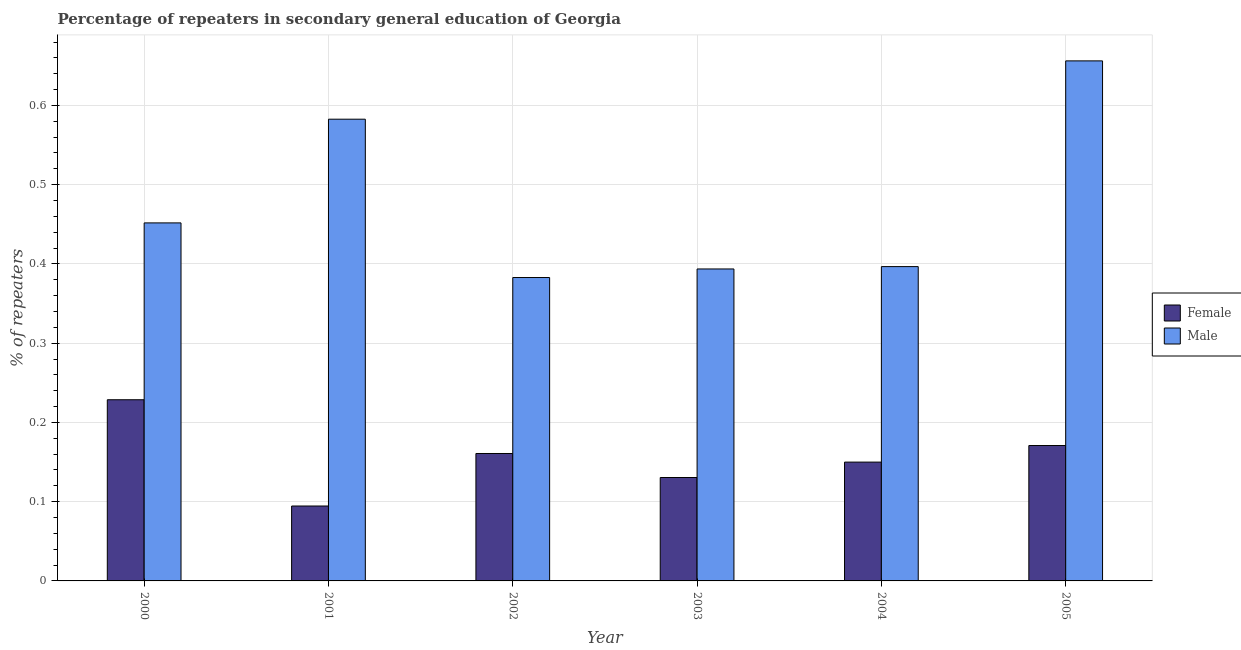Are the number of bars on each tick of the X-axis equal?
Provide a succinct answer. Yes. How many bars are there on the 2nd tick from the right?
Keep it short and to the point. 2. What is the label of the 5th group of bars from the left?
Give a very brief answer. 2004. In how many cases, is the number of bars for a given year not equal to the number of legend labels?
Give a very brief answer. 0. What is the percentage of male repeaters in 2001?
Provide a succinct answer. 0.58. Across all years, what is the maximum percentage of female repeaters?
Your answer should be very brief. 0.23. Across all years, what is the minimum percentage of male repeaters?
Give a very brief answer. 0.38. In which year was the percentage of male repeaters maximum?
Ensure brevity in your answer.  2005. What is the total percentage of male repeaters in the graph?
Your answer should be compact. 2.86. What is the difference between the percentage of female repeaters in 2000 and that in 2004?
Ensure brevity in your answer.  0.08. What is the difference between the percentage of female repeaters in 2001 and the percentage of male repeaters in 2004?
Make the answer very short. -0.06. What is the average percentage of female repeaters per year?
Provide a succinct answer. 0.16. What is the ratio of the percentage of male repeaters in 2002 to that in 2003?
Your answer should be compact. 0.97. Is the percentage of female repeaters in 2004 less than that in 2005?
Offer a very short reply. Yes. Is the difference between the percentage of male repeaters in 2003 and 2005 greater than the difference between the percentage of female repeaters in 2003 and 2005?
Make the answer very short. No. What is the difference between the highest and the second highest percentage of male repeaters?
Your answer should be very brief. 0.07. What is the difference between the highest and the lowest percentage of male repeaters?
Provide a short and direct response. 0.27. In how many years, is the percentage of female repeaters greater than the average percentage of female repeaters taken over all years?
Keep it short and to the point. 3. Is the sum of the percentage of female repeaters in 2003 and 2004 greater than the maximum percentage of male repeaters across all years?
Your response must be concise. Yes. What does the 2nd bar from the left in 2005 represents?
Provide a succinct answer. Male. How many bars are there?
Provide a succinct answer. 12. Are all the bars in the graph horizontal?
Give a very brief answer. No. Are the values on the major ticks of Y-axis written in scientific E-notation?
Ensure brevity in your answer.  No. How many legend labels are there?
Ensure brevity in your answer.  2. How are the legend labels stacked?
Your response must be concise. Vertical. What is the title of the graph?
Keep it short and to the point. Percentage of repeaters in secondary general education of Georgia. What is the label or title of the Y-axis?
Provide a succinct answer. % of repeaters. What is the % of repeaters in Female in 2000?
Make the answer very short. 0.23. What is the % of repeaters of Male in 2000?
Keep it short and to the point. 0.45. What is the % of repeaters of Female in 2001?
Your response must be concise. 0.09. What is the % of repeaters of Male in 2001?
Ensure brevity in your answer.  0.58. What is the % of repeaters of Female in 2002?
Your answer should be very brief. 0.16. What is the % of repeaters in Male in 2002?
Your answer should be compact. 0.38. What is the % of repeaters in Female in 2003?
Offer a terse response. 0.13. What is the % of repeaters in Male in 2003?
Your answer should be very brief. 0.39. What is the % of repeaters in Female in 2004?
Provide a short and direct response. 0.15. What is the % of repeaters in Male in 2004?
Keep it short and to the point. 0.4. What is the % of repeaters of Female in 2005?
Ensure brevity in your answer.  0.17. What is the % of repeaters in Male in 2005?
Your answer should be very brief. 0.66. Across all years, what is the maximum % of repeaters of Female?
Ensure brevity in your answer.  0.23. Across all years, what is the maximum % of repeaters in Male?
Give a very brief answer. 0.66. Across all years, what is the minimum % of repeaters of Female?
Ensure brevity in your answer.  0.09. Across all years, what is the minimum % of repeaters in Male?
Provide a succinct answer. 0.38. What is the total % of repeaters in Female in the graph?
Give a very brief answer. 0.94. What is the total % of repeaters of Male in the graph?
Ensure brevity in your answer.  2.86. What is the difference between the % of repeaters of Female in 2000 and that in 2001?
Keep it short and to the point. 0.13. What is the difference between the % of repeaters in Male in 2000 and that in 2001?
Make the answer very short. -0.13. What is the difference between the % of repeaters in Female in 2000 and that in 2002?
Provide a short and direct response. 0.07. What is the difference between the % of repeaters of Male in 2000 and that in 2002?
Provide a short and direct response. 0.07. What is the difference between the % of repeaters of Female in 2000 and that in 2003?
Ensure brevity in your answer.  0.1. What is the difference between the % of repeaters of Male in 2000 and that in 2003?
Ensure brevity in your answer.  0.06. What is the difference between the % of repeaters of Female in 2000 and that in 2004?
Provide a succinct answer. 0.08. What is the difference between the % of repeaters of Male in 2000 and that in 2004?
Ensure brevity in your answer.  0.06. What is the difference between the % of repeaters in Female in 2000 and that in 2005?
Your answer should be very brief. 0.06. What is the difference between the % of repeaters of Male in 2000 and that in 2005?
Give a very brief answer. -0.2. What is the difference between the % of repeaters in Female in 2001 and that in 2002?
Offer a very short reply. -0.07. What is the difference between the % of repeaters of Male in 2001 and that in 2002?
Provide a short and direct response. 0.2. What is the difference between the % of repeaters of Female in 2001 and that in 2003?
Offer a very short reply. -0.04. What is the difference between the % of repeaters in Male in 2001 and that in 2003?
Give a very brief answer. 0.19. What is the difference between the % of repeaters in Female in 2001 and that in 2004?
Provide a succinct answer. -0.06. What is the difference between the % of repeaters of Male in 2001 and that in 2004?
Your response must be concise. 0.19. What is the difference between the % of repeaters of Female in 2001 and that in 2005?
Ensure brevity in your answer.  -0.08. What is the difference between the % of repeaters in Male in 2001 and that in 2005?
Offer a terse response. -0.07. What is the difference between the % of repeaters in Female in 2002 and that in 2003?
Ensure brevity in your answer.  0.03. What is the difference between the % of repeaters of Male in 2002 and that in 2003?
Provide a short and direct response. -0.01. What is the difference between the % of repeaters of Female in 2002 and that in 2004?
Provide a succinct answer. 0.01. What is the difference between the % of repeaters of Male in 2002 and that in 2004?
Provide a succinct answer. -0.01. What is the difference between the % of repeaters of Female in 2002 and that in 2005?
Your answer should be very brief. -0.01. What is the difference between the % of repeaters in Male in 2002 and that in 2005?
Offer a terse response. -0.27. What is the difference between the % of repeaters in Female in 2003 and that in 2004?
Your answer should be very brief. -0.02. What is the difference between the % of repeaters of Male in 2003 and that in 2004?
Keep it short and to the point. -0. What is the difference between the % of repeaters of Female in 2003 and that in 2005?
Keep it short and to the point. -0.04. What is the difference between the % of repeaters in Male in 2003 and that in 2005?
Your answer should be very brief. -0.26. What is the difference between the % of repeaters in Female in 2004 and that in 2005?
Your answer should be very brief. -0.02. What is the difference between the % of repeaters of Male in 2004 and that in 2005?
Provide a short and direct response. -0.26. What is the difference between the % of repeaters in Female in 2000 and the % of repeaters in Male in 2001?
Your answer should be very brief. -0.35. What is the difference between the % of repeaters of Female in 2000 and the % of repeaters of Male in 2002?
Make the answer very short. -0.15. What is the difference between the % of repeaters in Female in 2000 and the % of repeaters in Male in 2003?
Provide a succinct answer. -0.17. What is the difference between the % of repeaters of Female in 2000 and the % of repeaters of Male in 2004?
Your answer should be very brief. -0.17. What is the difference between the % of repeaters in Female in 2000 and the % of repeaters in Male in 2005?
Your answer should be very brief. -0.43. What is the difference between the % of repeaters in Female in 2001 and the % of repeaters in Male in 2002?
Keep it short and to the point. -0.29. What is the difference between the % of repeaters in Female in 2001 and the % of repeaters in Male in 2003?
Your answer should be compact. -0.3. What is the difference between the % of repeaters in Female in 2001 and the % of repeaters in Male in 2004?
Offer a very short reply. -0.3. What is the difference between the % of repeaters of Female in 2001 and the % of repeaters of Male in 2005?
Your answer should be compact. -0.56. What is the difference between the % of repeaters in Female in 2002 and the % of repeaters in Male in 2003?
Make the answer very short. -0.23. What is the difference between the % of repeaters of Female in 2002 and the % of repeaters of Male in 2004?
Make the answer very short. -0.24. What is the difference between the % of repeaters of Female in 2002 and the % of repeaters of Male in 2005?
Offer a very short reply. -0.5. What is the difference between the % of repeaters of Female in 2003 and the % of repeaters of Male in 2004?
Offer a very short reply. -0.27. What is the difference between the % of repeaters of Female in 2003 and the % of repeaters of Male in 2005?
Make the answer very short. -0.53. What is the difference between the % of repeaters in Female in 2004 and the % of repeaters in Male in 2005?
Keep it short and to the point. -0.51. What is the average % of repeaters in Female per year?
Provide a succinct answer. 0.16. What is the average % of repeaters in Male per year?
Provide a short and direct response. 0.48. In the year 2000, what is the difference between the % of repeaters of Female and % of repeaters of Male?
Keep it short and to the point. -0.22. In the year 2001, what is the difference between the % of repeaters in Female and % of repeaters in Male?
Offer a terse response. -0.49. In the year 2002, what is the difference between the % of repeaters of Female and % of repeaters of Male?
Your response must be concise. -0.22. In the year 2003, what is the difference between the % of repeaters in Female and % of repeaters in Male?
Offer a very short reply. -0.26. In the year 2004, what is the difference between the % of repeaters of Female and % of repeaters of Male?
Your answer should be compact. -0.25. In the year 2005, what is the difference between the % of repeaters in Female and % of repeaters in Male?
Your answer should be very brief. -0.49. What is the ratio of the % of repeaters of Female in 2000 to that in 2001?
Ensure brevity in your answer.  2.42. What is the ratio of the % of repeaters of Male in 2000 to that in 2001?
Your answer should be compact. 0.78. What is the ratio of the % of repeaters of Female in 2000 to that in 2002?
Your response must be concise. 1.42. What is the ratio of the % of repeaters of Male in 2000 to that in 2002?
Ensure brevity in your answer.  1.18. What is the ratio of the % of repeaters of Female in 2000 to that in 2003?
Offer a terse response. 1.75. What is the ratio of the % of repeaters in Male in 2000 to that in 2003?
Make the answer very short. 1.15. What is the ratio of the % of repeaters in Female in 2000 to that in 2004?
Offer a terse response. 1.52. What is the ratio of the % of repeaters of Male in 2000 to that in 2004?
Give a very brief answer. 1.14. What is the ratio of the % of repeaters in Female in 2000 to that in 2005?
Provide a succinct answer. 1.34. What is the ratio of the % of repeaters of Male in 2000 to that in 2005?
Give a very brief answer. 0.69. What is the ratio of the % of repeaters of Female in 2001 to that in 2002?
Your response must be concise. 0.59. What is the ratio of the % of repeaters in Male in 2001 to that in 2002?
Your answer should be very brief. 1.52. What is the ratio of the % of repeaters of Female in 2001 to that in 2003?
Offer a very short reply. 0.72. What is the ratio of the % of repeaters of Male in 2001 to that in 2003?
Make the answer very short. 1.48. What is the ratio of the % of repeaters of Female in 2001 to that in 2004?
Offer a very short reply. 0.63. What is the ratio of the % of repeaters of Male in 2001 to that in 2004?
Your response must be concise. 1.47. What is the ratio of the % of repeaters of Female in 2001 to that in 2005?
Your response must be concise. 0.55. What is the ratio of the % of repeaters in Male in 2001 to that in 2005?
Your answer should be very brief. 0.89. What is the ratio of the % of repeaters in Female in 2002 to that in 2003?
Your answer should be very brief. 1.23. What is the ratio of the % of repeaters in Male in 2002 to that in 2003?
Give a very brief answer. 0.97. What is the ratio of the % of repeaters in Female in 2002 to that in 2004?
Provide a short and direct response. 1.07. What is the ratio of the % of repeaters in Male in 2002 to that in 2004?
Make the answer very short. 0.97. What is the ratio of the % of repeaters of Male in 2002 to that in 2005?
Your answer should be compact. 0.58. What is the ratio of the % of repeaters in Female in 2003 to that in 2004?
Ensure brevity in your answer.  0.87. What is the ratio of the % of repeaters of Female in 2003 to that in 2005?
Provide a succinct answer. 0.76. What is the ratio of the % of repeaters of Male in 2003 to that in 2005?
Your response must be concise. 0.6. What is the ratio of the % of repeaters of Female in 2004 to that in 2005?
Offer a very short reply. 0.88. What is the ratio of the % of repeaters of Male in 2004 to that in 2005?
Offer a very short reply. 0.6. What is the difference between the highest and the second highest % of repeaters in Female?
Offer a terse response. 0.06. What is the difference between the highest and the second highest % of repeaters in Male?
Make the answer very short. 0.07. What is the difference between the highest and the lowest % of repeaters in Female?
Your response must be concise. 0.13. What is the difference between the highest and the lowest % of repeaters in Male?
Ensure brevity in your answer.  0.27. 